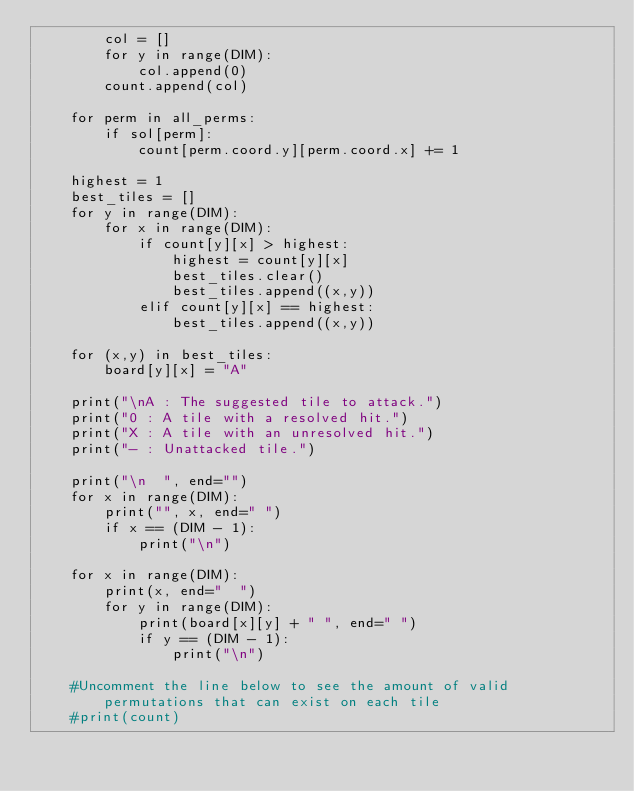<code> <loc_0><loc_0><loc_500><loc_500><_Python_>        col = []
        for y in range(DIM):
            col.append(0)
        count.append(col)
        
    for perm in all_perms:
        if sol[perm]:
            count[perm.coord.y][perm.coord.x] += 1
    
    highest = 1
    best_tiles = []
    for y in range(DIM):
        for x in range(DIM):
            if count[y][x] > highest:
                highest = count[y][x]
                best_tiles.clear()
                best_tiles.append((x,y))
            elif count[y][x] == highest:
                best_tiles.append((x,y))

    for (x,y) in best_tiles:
        board[y][x] = "A"

    print("\nA : The suggested tile to attack.")
    print("0 : A tile with a resolved hit.")
    print("X : A tile with an unresolved hit.")
    print("- : Unattacked tile.")

    print("\n  ", end="")
    for x in range(DIM):
        print("", x, end=" ")
        if x == (DIM - 1):
            print("\n")

    for x in range(DIM):
        print(x, end="  ")
        for y in range(DIM):
            print(board[x][y] + " ", end=" ")
            if y == (DIM - 1):
                print("\n")
    
    #Uncomment the line below to see the amount of valid permutations that can exist on each tile
    #print(count)</code> 